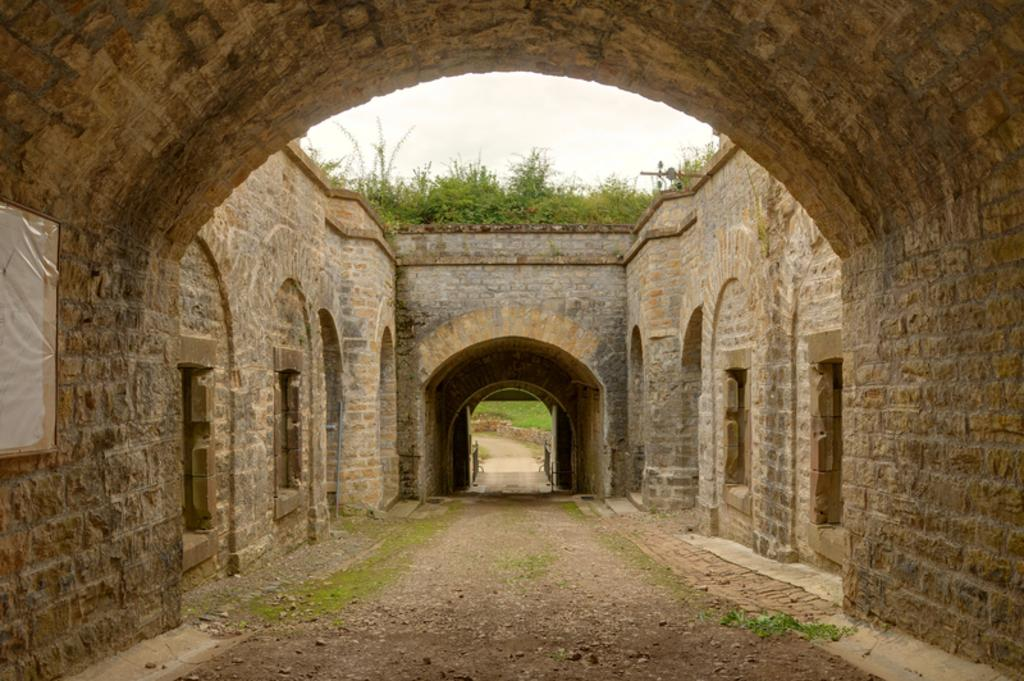What type of architectural feature can be seen in the image? There are arches in the image. What else can be seen in the image besides the arches? There are walls in the image. What can be seen in the background of the image? There are plants in the background of the image. Where is the poster located in the image? The poster is on the wall on the left side of the image. What level of education does the flame in the image have? There is no flame present in the image, so it is not possible to determine its level of education. 